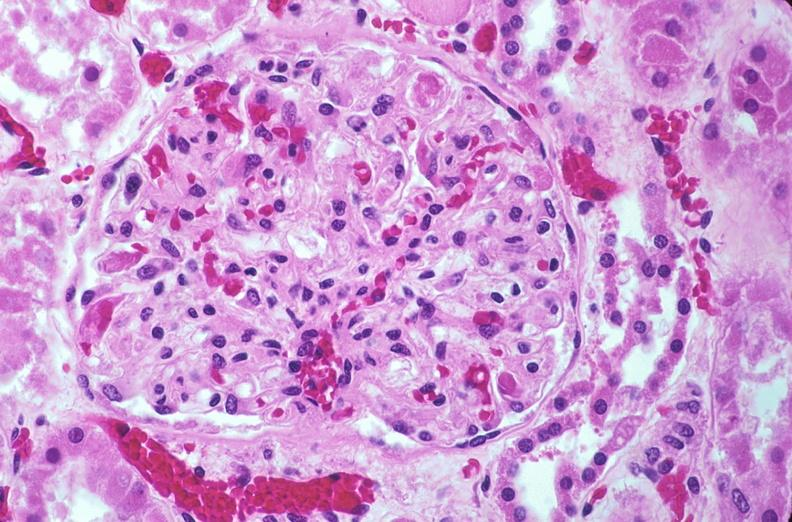what does this image show?
Answer the question using a single word or phrase. Kidney 